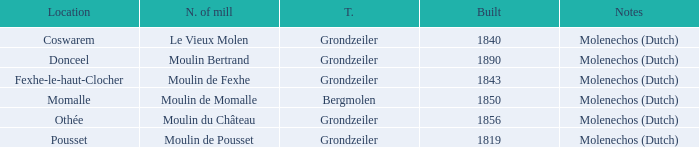What is year Built of the Moulin de Momalle Mill? 1850.0. 